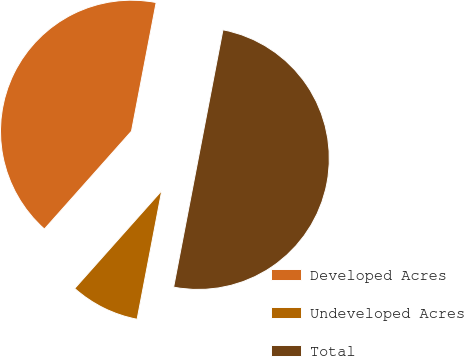Convert chart to OTSL. <chart><loc_0><loc_0><loc_500><loc_500><pie_chart><fcel>Developed Acres<fcel>Undeveloped Acres<fcel>Total<nl><fcel>41.44%<fcel>8.56%<fcel>50.0%<nl></chart> 